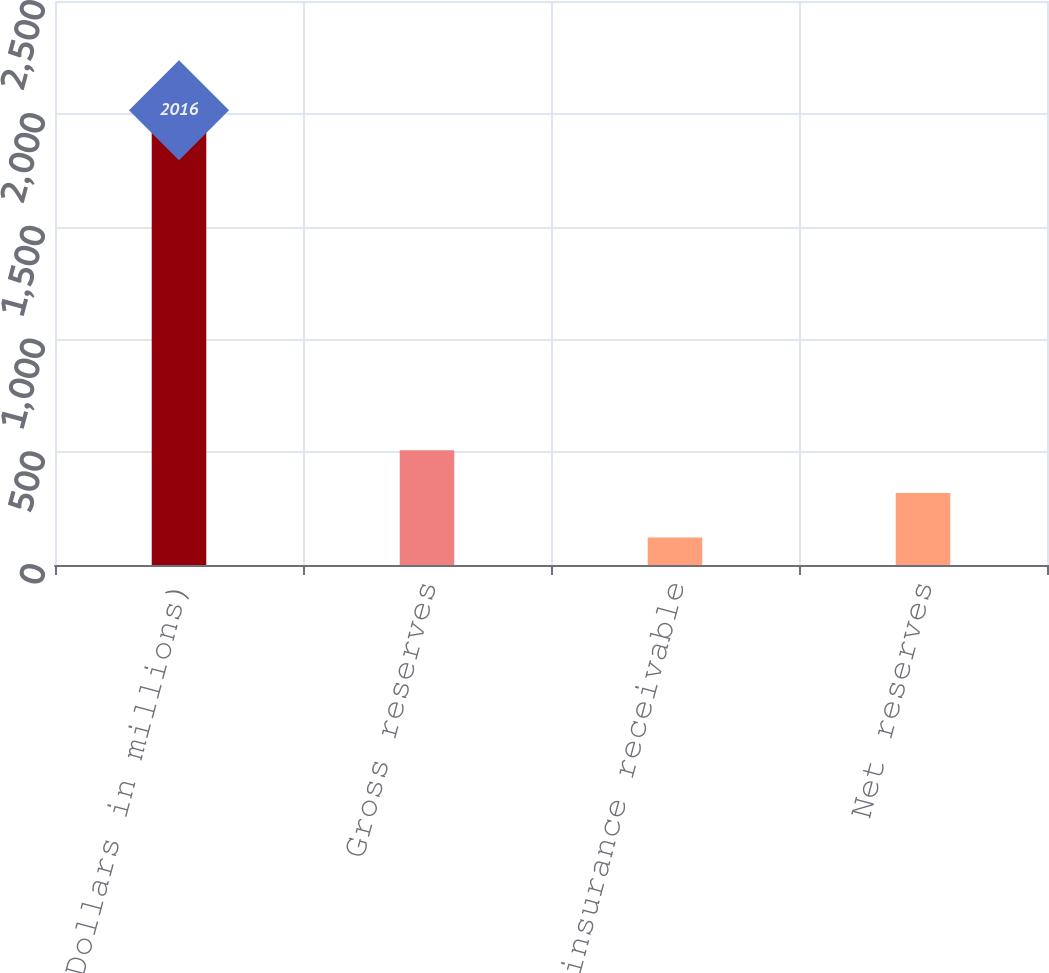Convert chart. <chart><loc_0><loc_0><loc_500><loc_500><bar_chart><fcel>(Dollars in millions)<fcel>Gross reserves<fcel>Reinsurance receivable<fcel>Net reserves<nl><fcel>2016<fcel>508.5<fcel>122<fcel>319.1<nl></chart> 